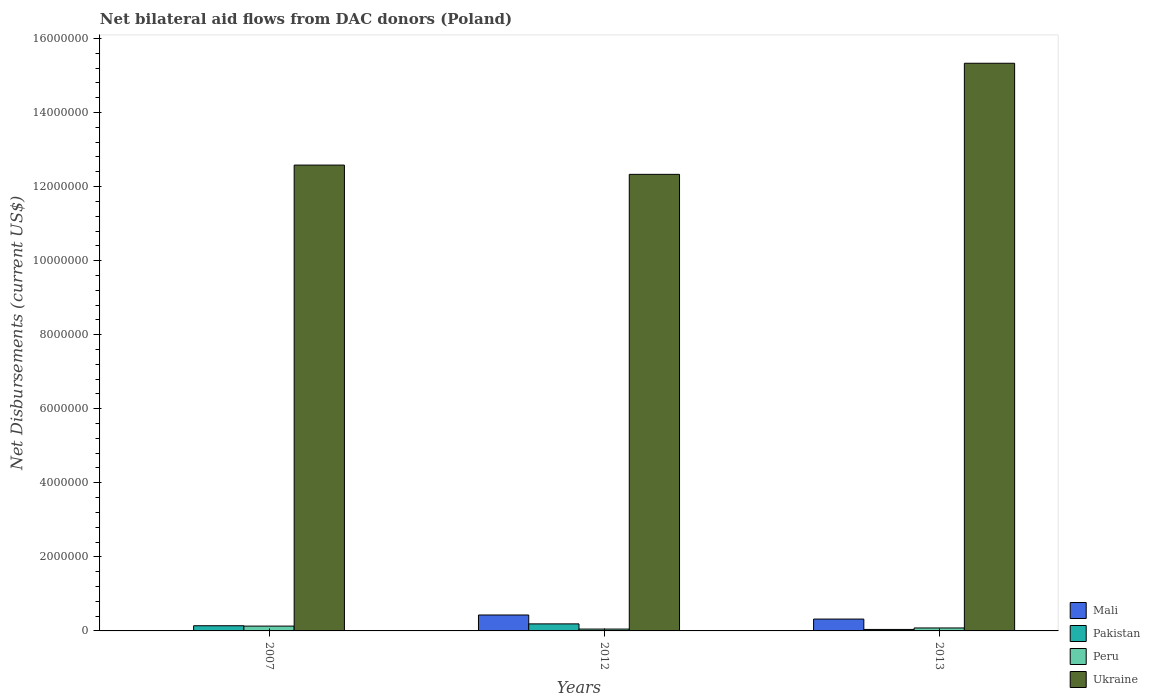Are the number of bars per tick equal to the number of legend labels?
Your answer should be very brief. Yes. Are the number of bars on each tick of the X-axis equal?
Offer a very short reply. Yes. How many bars are there on the 3rd tick from the left?
Keep it short and to the point. 4. What is the net bilateral aid flows in Peru in 2007?
Offer a terse response. 1.30e+05. Across all years, what is the maximum net bilateral aid flows in Peru?
Offer a very short reply. 1.30e+05. Across all years, what is the minimum net bilateral aid flows in Peru?
Keep it short and to the point. 5.00e+04. In which year was the net bilateral aid flows in Peru maximum?
Your answer should be compact. 2007. What is the total net bilateral aid flows in Mali in the graph?
Keep it short and to the point. 7.60e+05. What is the difference between the net bilateral aid flows in Peru in 2007 and that in 2013?
Offer a terse response. 5.00e+04. What is the difference between the net bilateral aid flows in Pakistan in 2007 and the net bilateral aid flows in Peru in 2013?
Give a very brief answer. 6.00e+04. What is the average net bilateral aid flows in Ukraine per year?
Your response must be concise. 1.34e+07. In how many years, is the net bilateral aid flows in Peru greater than 3600000 US$?
Your response must be concise. 0. What is the ratio of the net bilateral aid flows in Mali in 2007 to that in 2013?
Your response must be concise. 0.03. What is the difference between the highest and the second highest net bilateral aid flows in Ukraine?
Provide a succinct answer. 2.75e+06. What is the difference between the highest and the lowest net bilateral aid flows in Pakistan?
Offer a terse response. 1.50e+05. In how many years, is the net bilateral aid flows in Pakistan greater than the average net bilateral aid flows in Pakistan taken over all years?
Ensure brevity in your answer.  2. Is the sum of the net bilateral aid flows in Ukraine in 2007 and 2013 greater than the maximum net bilateral aid flows in Peru across all years?
Your response must be concise. Yes. Is it the case that in every year, the sum of the net bilateral aid flows in Ukraine and net bilateral aid flows in Peru is greater than the sum of net bilateral aid flows in Mali and net bilateral aid flows in Pakistan?
Ensure brevity in your answer.  Yes. How many bars are there?
Provide a succinct answer. 12. Are all the bars in the graph horizontal?
Give a very brief answer. No. How many years are there in the graph?
Provide a succinct answer. 3. What is the difference between two consecutive major ticks on the Y-axis?
Your answer should be compact. 2.00e+06. Are the values on the major ticks of Y-axis written in scientific E-notation?
Keep it short and to the point. No. Does the graph contain any zero values?
Offer a very short reply. No. Does the graph contain grids?
Provide a succinct answer. No. What is the title of the graph?
Provide a succinct answer. Net bilateral aid flows from DAC donors (Poland). What is the label or title of the X-axis?
Keep it short and to the point. Years. What is the label or title of the Y-axis?
Offer a very short reply. Net Disbursements (current US$). What is the Net Disbursements (current US$) in Mali in 2007?
Your answer should be compact. 10000. What is the Net Disbursements (current US$) in Ukraine in 2007?
Provide a succinct answer. 1.26e+07. What is the Net Disbursements (current US$) in Mali in 2012?
Give a very brief answer. 4.30e+05. What is the Net Disbursements (current US$) of Pakistan in 2012?
Ensure brevity in your answer.  1.90e+05. What is the Net Disbursements (current US$) of Peru in 2012?
Offer a terse response. 5.00e+04. What is the Net Disbursements (current US$) in Ukraine in 2012?
Your response must be concise. 1.23e+07. What is the Net Disbursements (current US$) of Pakistan in 2013?
Offer a terse response. 4.00e+04. What is the Net Disbursements (current US$) of Peru in 2013?
Offer a very short reply. 8.00e+04. What is the Net Disbursements (current US$) of Ukraine in 2013?
Your answer should be compact. 1.53e+07. Across all years, what is the maximum Net Disbursements (current US$) of Peru?
Offer a very short reply. 1.30e+05. Across all years, what is the maximum Net Disbursements (current US$) of Ukraine?
Provide a short and direct response. 1.53e+07. Across all years, what is the minimum Net Disbursements (current US$) in Pakistan?
Ensure brevity in your answer.  4.00e+04. Across all years, what is the minimum Net Disbursements (current US$) of Peru?
Your answer should be very brief. 5.00e+04. Across all years, what is the minimum Net Disbursements (current US$) of Ukraine?
Your response must be concise. 1.23e+07. What is the total Net Disbursements (current US$) in Mali in the graph?
Your answer should be compact. 7.60e+05. What is the total Net Disbursements (current US$) in Pakistan in the graph?
Keep it short and to the point. 3.70e+05. What is the total Net Disbursements (current US$) in Ukraine in the graph?
Your response must be concise. 4.02e+07. What is the difference between the Net Disbursements (current US$) in Mali in 2007 and that in 2012?
Ensure brevity in your answer.  -4.20e+05. What is the difference between the Net Disbursements (current US$) in Peru in 2007 and that in 2012?
Offer a terse response. 8.00e+04. What is the difference between the Net Disbursements (current US$) of Mali in 2007 and that in 2013?
Keep it short and to the point. -3.10e+05. What is the difference between the Net Disbursements (current US$) of Pakistan in 2007 and that in 2013?
Ensure brevity in your answer.  1.00e+05. What is the difference between the Net Disbursements (current US$) of Ukraine in 2007 and that in 2013?
Offer a terse response. -2.75e+06. What is the difference between the Net Disbursements (current US$) of Mali in 2012 and that in 2013?
Give a very brief answer. 1.10e+05. What is the difference between the Net Disbursements (current US$) of Peru in 2012 and that in 2013?
Your response must be concise. -3.00e+04. What is the difference between the Net Disbursements (current US$) in Ukraine in 2012 and that in 2013?
Your response must be concise. -3.00e+06. What is the difference between the Net Disbursements (current US$) of Mali in 2007 and the Net Disbursements (current US$) of Pakistan in 2012?
Offer a terse response. -1.80e+05. What is the difference between the Net Disbursements (current US$) in Mali in 2007 and the Net Disbursements (current US$) in Ukraine in 2012?
Your response must be concise. -1.23e+07. What is the difference between the Net Disbursements (current US$) of Pakistan in 2007 and the Net Disbursements (current US$) of Ukraine in 2012?
Your response must be concise. -1.22e+07. What is the difference between the Net Disbursements (current US$) of Peru in 2007 and the Net Disbursements (current US$) of Ukraine in 2012?
Offer a very short reply. -1.22e+07. What is the difference between the Net Disbursements (current US$) of Mali in 2007 and the Net Disbursements (current US$) of Pakistan in 2013?
Your answer should be compact. -3.00e+04. What is the difference between the Net Disbursements (current US$) of Mali in 2007 and the Net Disbursements (current US$) of Peru in 2013?
Give a very brief answer. -7.00e+04. What is the difference between the Net Disbursements (current US$) in Mali in 2007 and the Net Disbursements (current US$) in Ukraine in 2013?
Ensure brevity in your answer.  -1.53e+07. What is the difference between the Net Disbursements (current US$) in Pakistan in 2007 and the Net Disbursements (current US$) in Peru in 2013?
Make the answer very short. 6.00e+04. What is the difference between the Net Disbursements (current US$) of Pakistan in 2007 and the Net Disbursements (current US$) of Ukraine in 2013?
Your answer should be compact. -1.52e+07. What is the difference between the Net Disbursements (current US$) in Peru in 2007 and the Net Disbursements (current US$) in Ukraine in 2013?
Make the answer very short. -1.52e+07. What is the difference between the Net Disbursements (current US$) in Mali in 2012 and the Net Disbursements (current US$) in Pakistan in 2013?
Your response must be concise. 3.90e+05. What is the difference between the Net Disbursements (current US$) in Mali in 2012 and the Net Disbursements (current US$) in Peru in 2013?
Make the answer very short. 3.50e+05. What is the difference between the Net Disbursements (current US$) in Mali in 2012 and the Net Disbursements (current US$) in Ukraine in 2013?
Make the answer very short. -1.49e+07. What is the difference between the Net Disbursements (current US$) in Pakistan in 2012 and the Net Disbursements (current US$) in Peru in 2013?
Ensure brevity in your answer.  1.10e+05. What is the difference between the Net Disbursements (current US$) in Pakistan in 2012 and the Net Disbursements (current US$) in Ukraine in 2013?
Provide a succinct answer. -1.51e+07. What is the difference between the Net Disbursements (current US$) of Peru in 2012 and the Net Disbursements (current US$) of Ukraine in 2013?
Your response must be concise. -1.53e+07. What is the average Net Disbursements (current US$) of Mali per year?
Your answer should be compact. 2.53e+05. What is the average Net Disbursements (current US$) of Pakistan per year?
Make the answer very short. 1.23e+05. What is the average Net Disbursements (current US$) in Peru per year?
Your answer should be very brief. 8.67e+04. What is the average Net Disbursements (current US$) in Ukraine per year?
Offer a very short reply. 1.34e+07. In the year 2007, what is the difference between the Net Disbursements (current US$) of Mali and Net Disbursements (current US$) of Ukraine?
Provide a short and direct response. -1.26e+07. In the year 2007, what is the difference between the Net Disbursements (current US$) of Pakistan and Net Disbursements (current US$) of Ukraine?
Your response must be concise. -1.24e+07. In the year 2007, what is the difference between the Net Disbursements (current US$) of Peru and Net Disbursements (current US$) of Ukraine?
Ensure brevity in your answer.  -1.24e+07. In the year 2012, what is the difference between the Net Disbursements (current US$) of Mali and Net Disbursements (current US$) of Pakistan?
Make the answer very short. 2.40e+05. In the year 2012, what is the difference between the Net Disbursements (current US$) in Mali and Net Disbursements (current US$) in Peru?
Your answer should be very brief. 3.80e+05. In the year 2012, what is the difference between the Net Disbursements (current US$) of Mali and Net Disbursements (current US$) of Ukraine?
Provide a succinct answer. -1.19e+07. In the year 2012, what is the difference between the Net Disbursements (current US$) in Pakistan and Net Disbursements (current US$) in Peru?
Make the answer very short. 1.40e+05. In the year 2012, what is the difference between the Net Disbursements (current US$) in Pakistan and Net Disbursements (current US$) in Ukraine?
Give a very brief answer. -1.21e+07. In the year 2012, what is the difference between the Net Disbursements (current US$) of Peru and Net Disbursements (current US$) of Ukraine?
Provide a short and direct response. -1.23e+07. In the year 2013, what is the difference between the Net Disbursements (current US$) in Mali and Net Disbursements (current US$) in Pakistan?
Offer a very short reply. 2.80e+05. In the year 2013, what is the difference between the Net Disbursements (current US$) in Mali and Net Disbursements (current US$) in Peru?
Your response must be concise. 2.40e+05. In the year 2013, what is the difference between the Net Disbursements (current US$) of Mali and Net Disbursements (current US$) of Ukraine?
Give a very brief answer. -1.50e+07. In the year 2013, what is the difference between the Net Disbursements (current US$) in Pakistan and Net Disbursements (current US$) in Peru?
Offer a very short reply. -4.00e+04. In the year 2013, what is the difference between the Net Disbursements (current US$) in Pakistan and Net Disbursements (current US$) in Ukraine?
Make the answer very short. -1.53e+07. In the year 2013, what is the difference between the Net Disbursements (current US$) of Peru and Net Disbursements (current US$) of Ukraine?
Make the answer very short. -1.52e+07. What is the ratio of the Net Disbursements (current US$) of Mali in 2007 to that in 2012?
Provide a succinct answer. 0.02. What is the ratio of the Net Disbursements (current US$) of Pakistan in 2007 to that in 2012?
Your answer should be compact. 0.74. What is the ratio of the Net Disbursements (current US$) of Ukraine in 2007 to that in 2012?
Provide a short and direct response. 1.02. What is the ratio of the Net Disbursements (current US$) of Mali in 2007 to that in 2013?
Ensure brevity in your answer.  0.03. What is the ratio of the Net Disbursements (current US$) in Pakistan in 2007 to that in 2013?
Make the answer very short. 3.5. What is the ratio of the Net Disbursements (current US$) in Peru in 2007 to that in 2013?
Provide a succinct answer. 1.62. What is the ratio of the Net Disbursements (current US$) in Ukraine in 2007 to that in 2013?
Provide a succinct answer. 0.82. What is the ratio of the Net Disbursements (current US$) in Mali in 2012 to that in 2013?
Your answer should be very brief. 1.34. What is the ratio of the Net Disbursements (current US$) in Pakistan in 2012 to that in 2013?
Your answer should be very brief. 4.75. What is the ratio of the Net Disbursements (current US$) of Peru in 2012 to that in 2013?
Ensure brevity in your answer.  0.62. What is the ratio of the Net Disbursements (current US$) of Ukraine in 2012 to that in 2013?
Ensure brevity in your answer.  0.8. What is the difference between the highest and the second highest Net Disbursements (current US$) of Ukraine?
Your answer should be very brief. 2.75e+06. What is the difference between the highest and the lowest Net Disbursements (current US$) of Mali?
Give a very brief answer. 4.20e+05. What is the difference between the highest and the lowest Net Disbursements (current US$) in Pakistan?
Provide a succinct answer. 1.50e+05. 